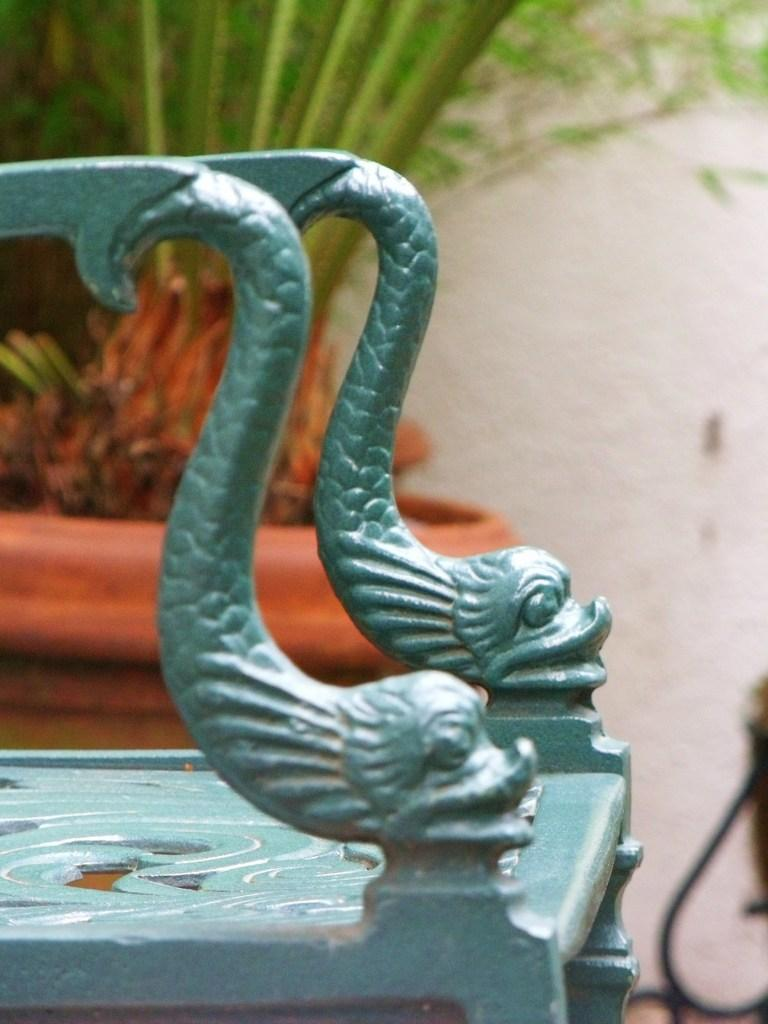What type of chair is in the image? There is a wooden chair in the image. What decorative elements are on the chair? The chair has two fish sculptures on its arms. What can be seen in the background of the image? There is a potted plant and a white wall in the background of the image. How many soap bars are on the chair in the image? There are no soap bars present in the image; it features a wooden chair with fish sculptures on its arms. Can you see a plane flying in the background of the image? There is no plane visible in the image; it only shows a wooden chair, fish sculptures, a potted plant, and a white wall in the background. 